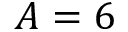<formula> <loc_0><loc_0><loc_500><loc_500>A = 6</formula> 